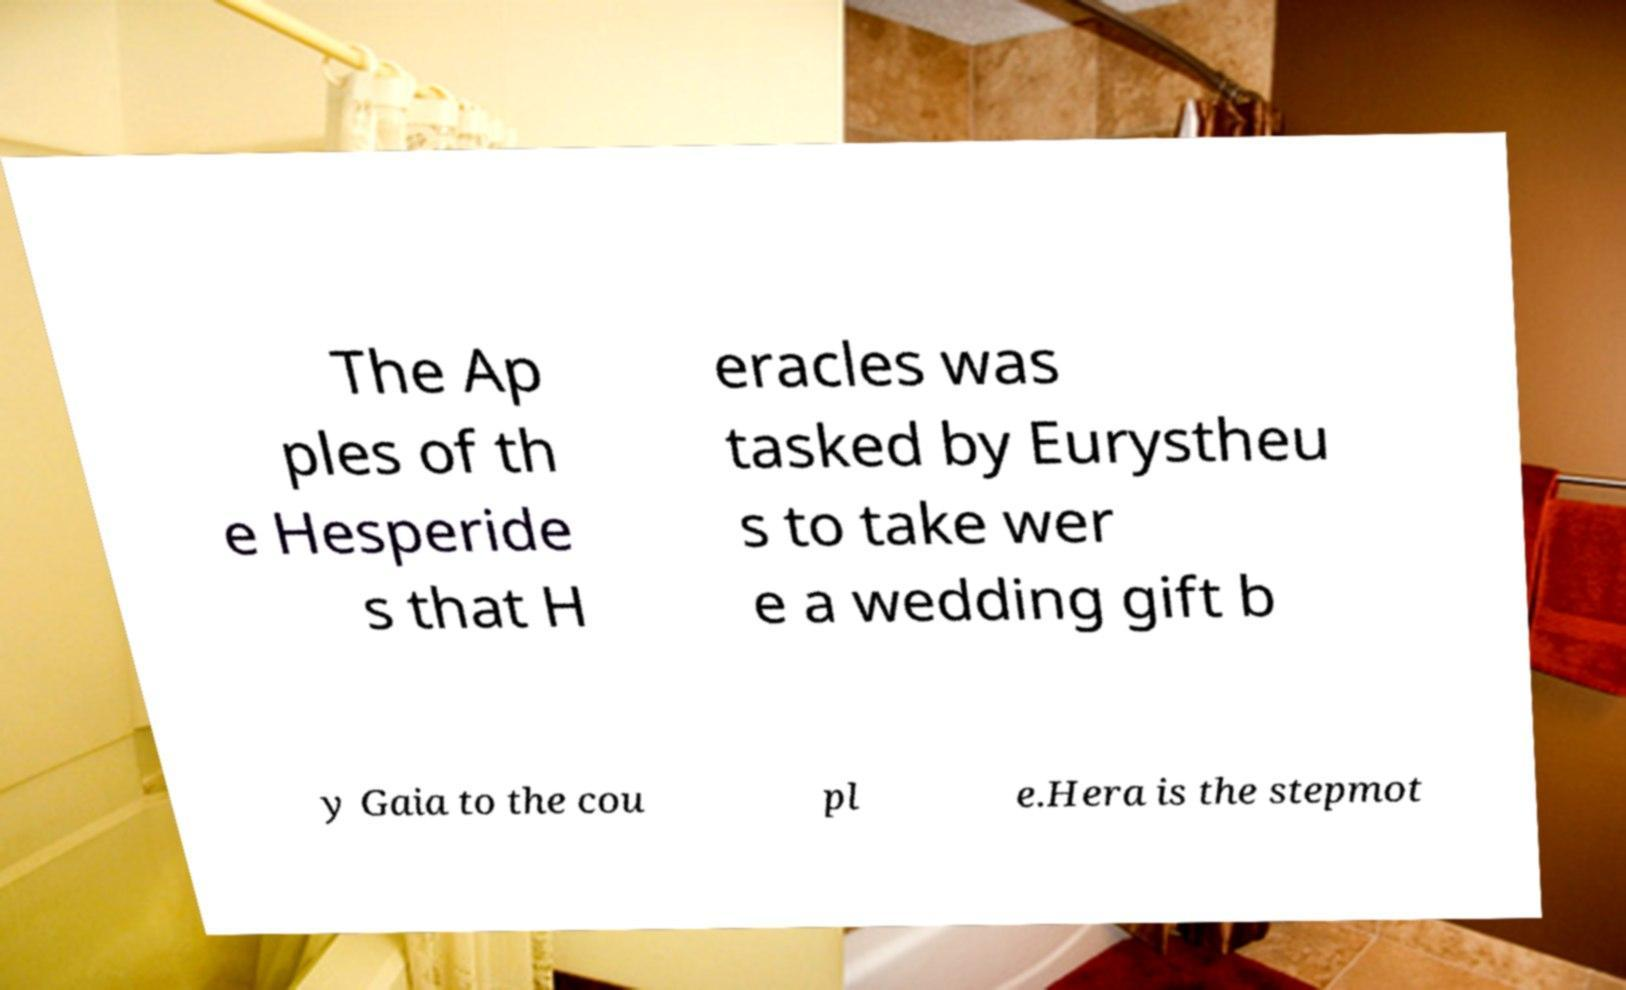Can you read and provide the text displayed in the image?This photo seems to have some interesting text. Can you extract and type it out for me? The Ap ples of th e Hesperide s that H eracles was tasked by Eurystheu s to take wer e a wedding gift b y Gaia to the cou pl e.Hera is the stepmot 